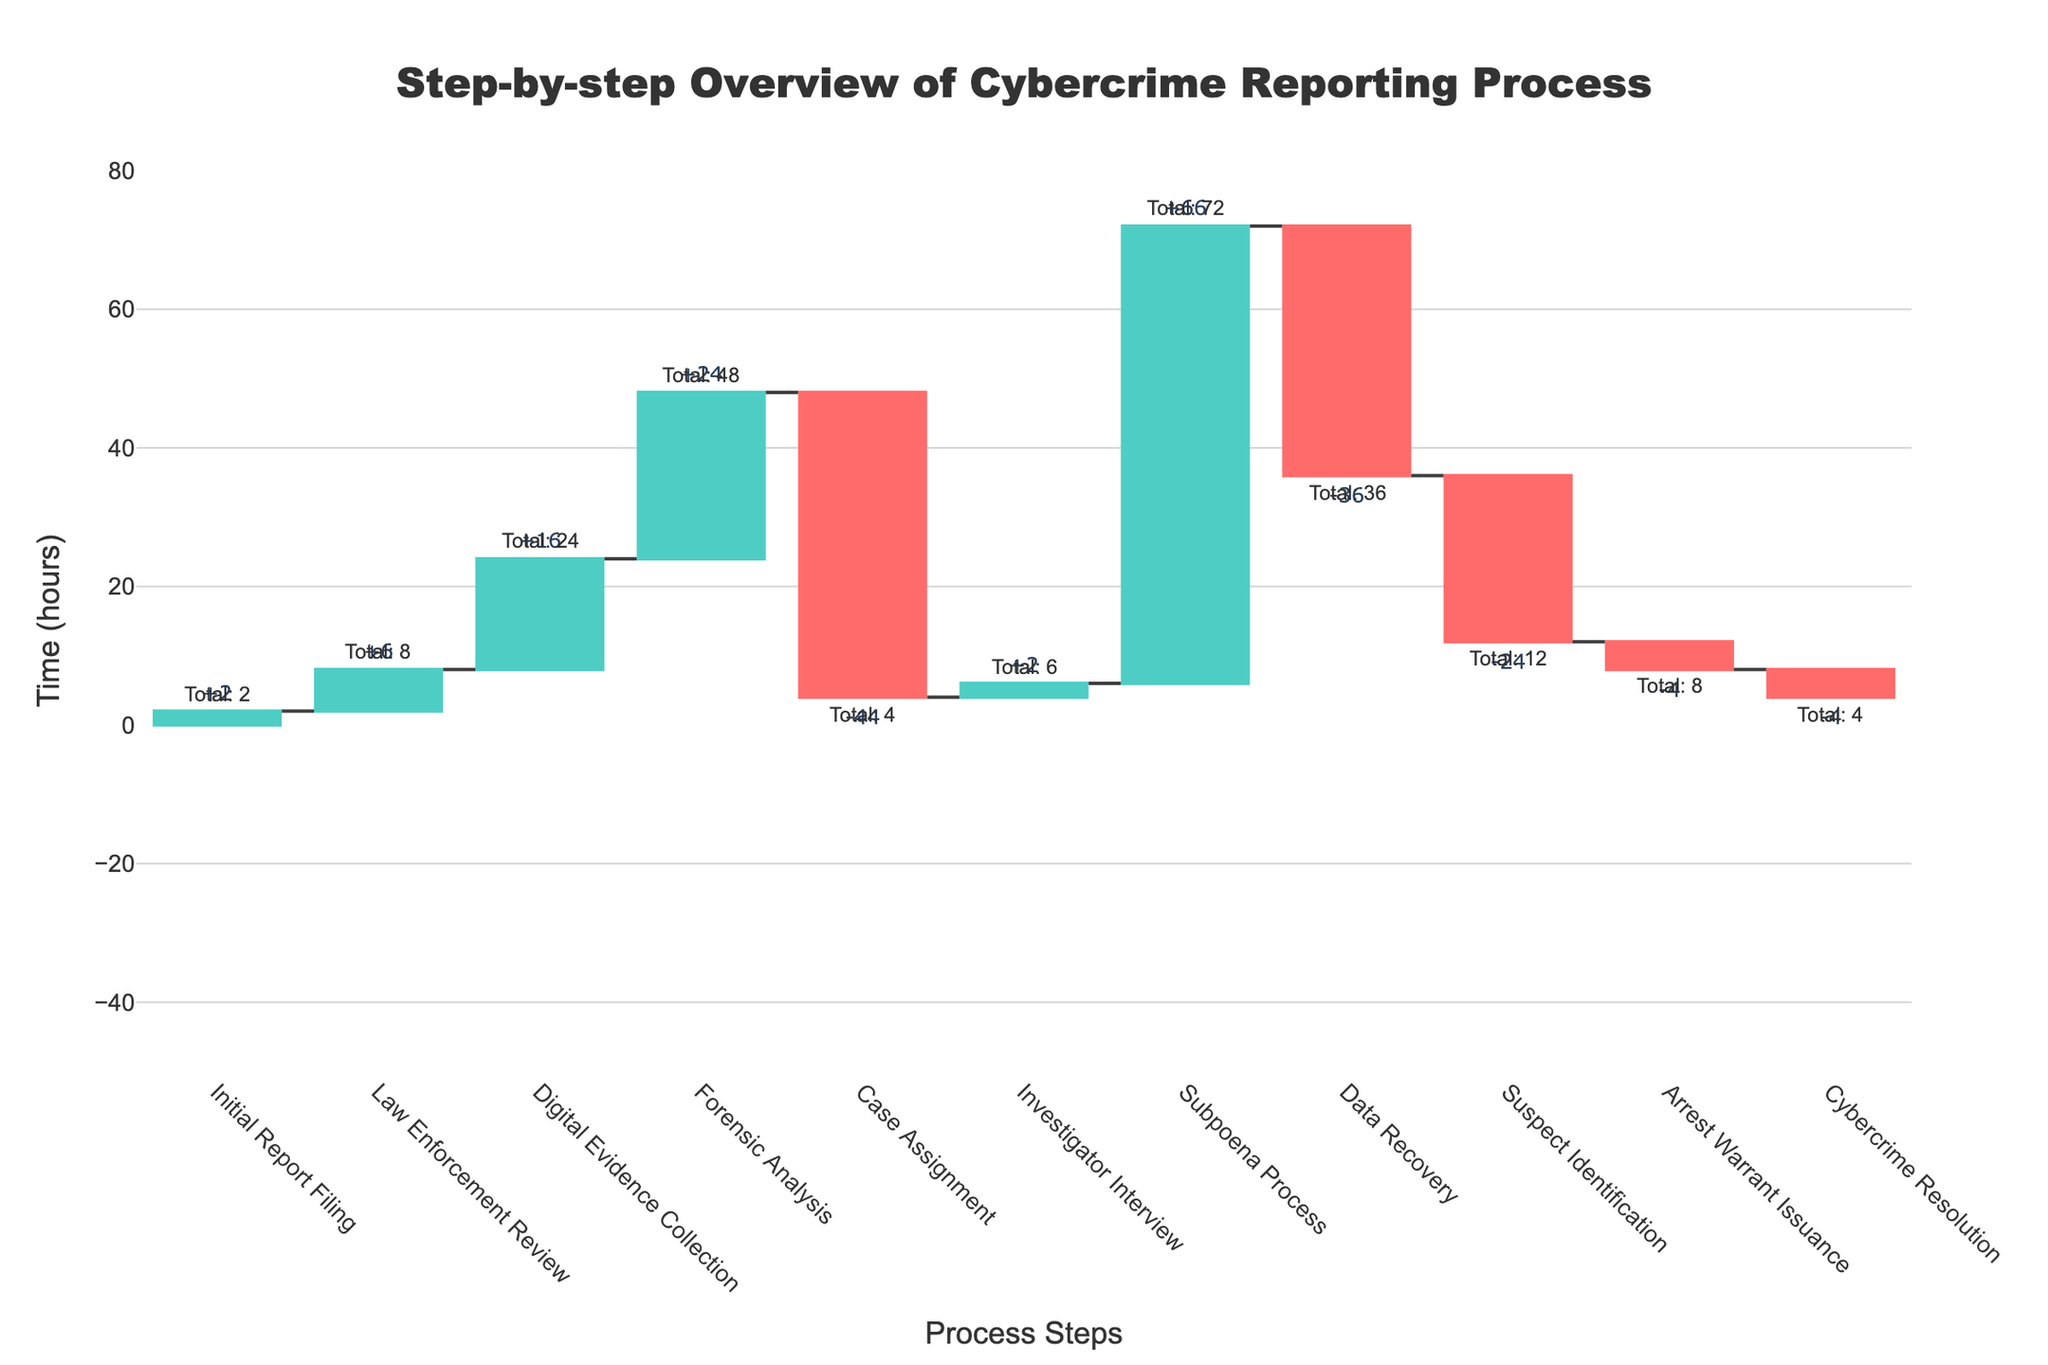What is the title of the chart? The title of the chart is displayed at the top, reading "Step-by-step Overview of Cybercrime Reporting Process."
Answer: Step-by-step Overview of Cybercrime Reporting Process How many process steps are shown in the chart? Count the number of different process steps listed along the x-axis.
Answer: 11 What is the time taken for the 'Law Enforcement Review' step? Observe the bar corresponding to the 'Law Enforcement Review' step and read the text label indicating the time taken.
Answer: 8 hours Which step has the greatest positive contribution to the overall time? Compare the heights of the bars representing positive changes and identify the tallest one. 'Subpoena Process' has the highest positive value of +66 hours.
Answer: Subpoena Process What is the cumulative time by the end of 'Digital Evidence Collection' step? Sum the times up to the 'Digital Evidence Collection' step: 2 + 6 + 16 = 24 hours.
Answer: 24 hours How much time does the 'Case Assignment' step save in the process? Identify the negative bar for 'Case Assignment' and note its label showing the time saved: -44 hours.
Answer: 44 hours What is the total time by the end of the 'Cybercrime Resolution' step? Sum the cumulative times up to 'Cybercrime Resolution': 2 + 8 + 24 + 48 + 4 - 44 + 6 + 66 - 36 - 24 - 4 - 4 = 40 hours.
Answer: 40 hours Which step directly follows 'Forensic Analysis' and how much time does it take? Identify the step listed immediately after 'Forensic Analysis' on the x-axis and read its corresponding time: 'Case Assignment', which takes 4 hours.
Answer: Case Assignment, 4 hours How does the 'Subpoena Process' time compare to the 'Investigator Interview' time? Compare the times for 'Subpoena Process' and 'Investigator Interview': 72 hours vs 6 hours. The 'Subpoena Process' takes significantly longer.
Answer: Subpoena Process takes longer What is the overall trend in the process time as seen in the waterfall chart? Analyze whether the sum of positive and negative changes shows an overall increase or decrease in time and note the cumulative total at the end to confirm the overall trend. The cumulative total time indicates an overall increase, suggesting more processes add time.
Answer: Overall increase 